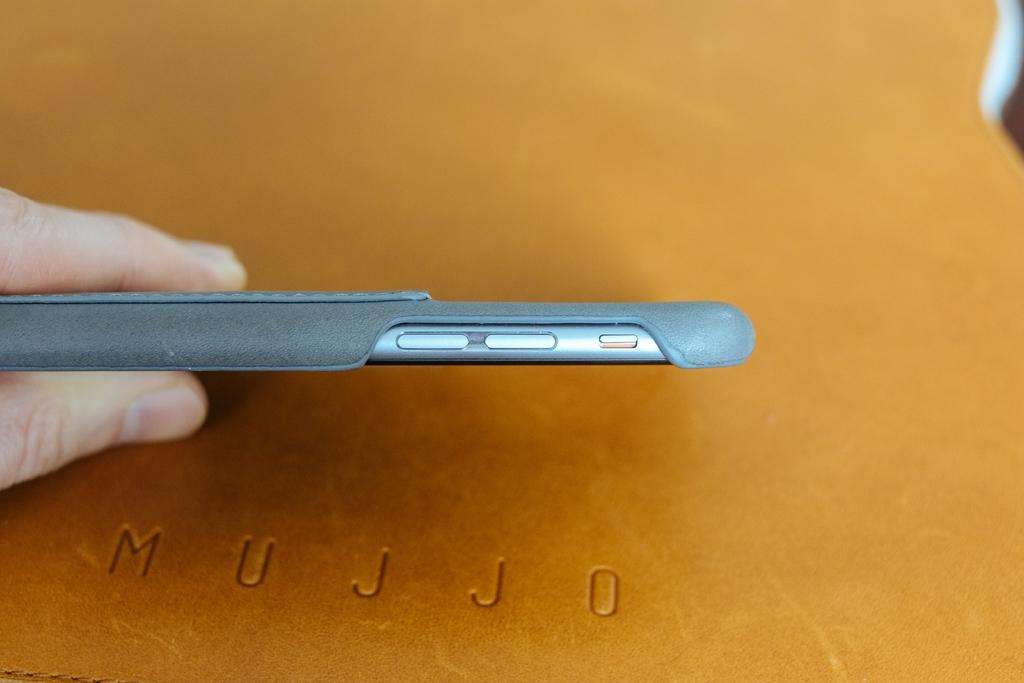Provide a one-sentence caption for the provided image. A hand holds a cellphone above a piece of leather embossed with Mujjo. 